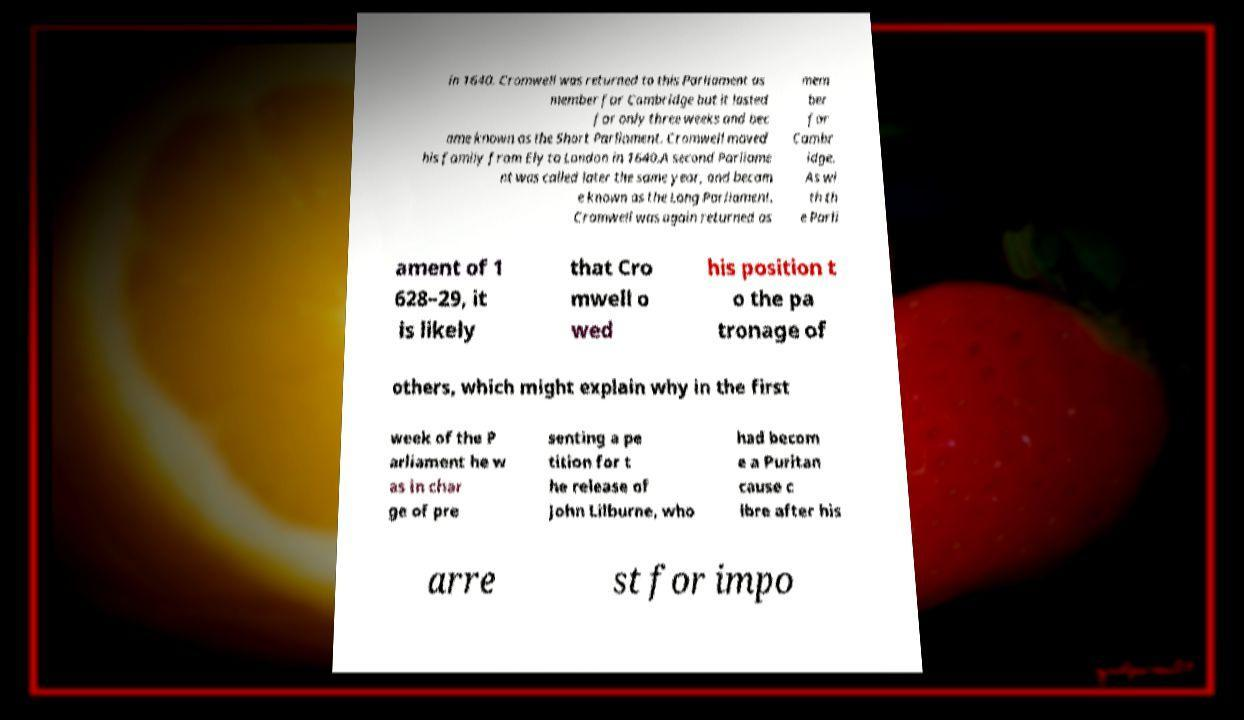Could you assist in decoding the text presented in this image and type it out clearly? in 1640. Cromwell was returned to this Parliament as member for Cambridge but it lasted for only three weeks and bec ame known as the Short Parliament. Cromwell moved his family from Ely to London in 1640.A second Parliame nt was called later the same year, and becam e known as the Long Parliament. Cromwell was again returned as mem ber for Cambr idge. As wi th th e Parli ament of 1 628–29, it is likely that Cro mwell o wed his position t o the pa tronage of others, which might explain why in the first week of the P arliament he w as in char ge of pre senting a pe tition for t he release of John Lilburne, who had becom e a Puritan cause c lbre after his arre st for impo 